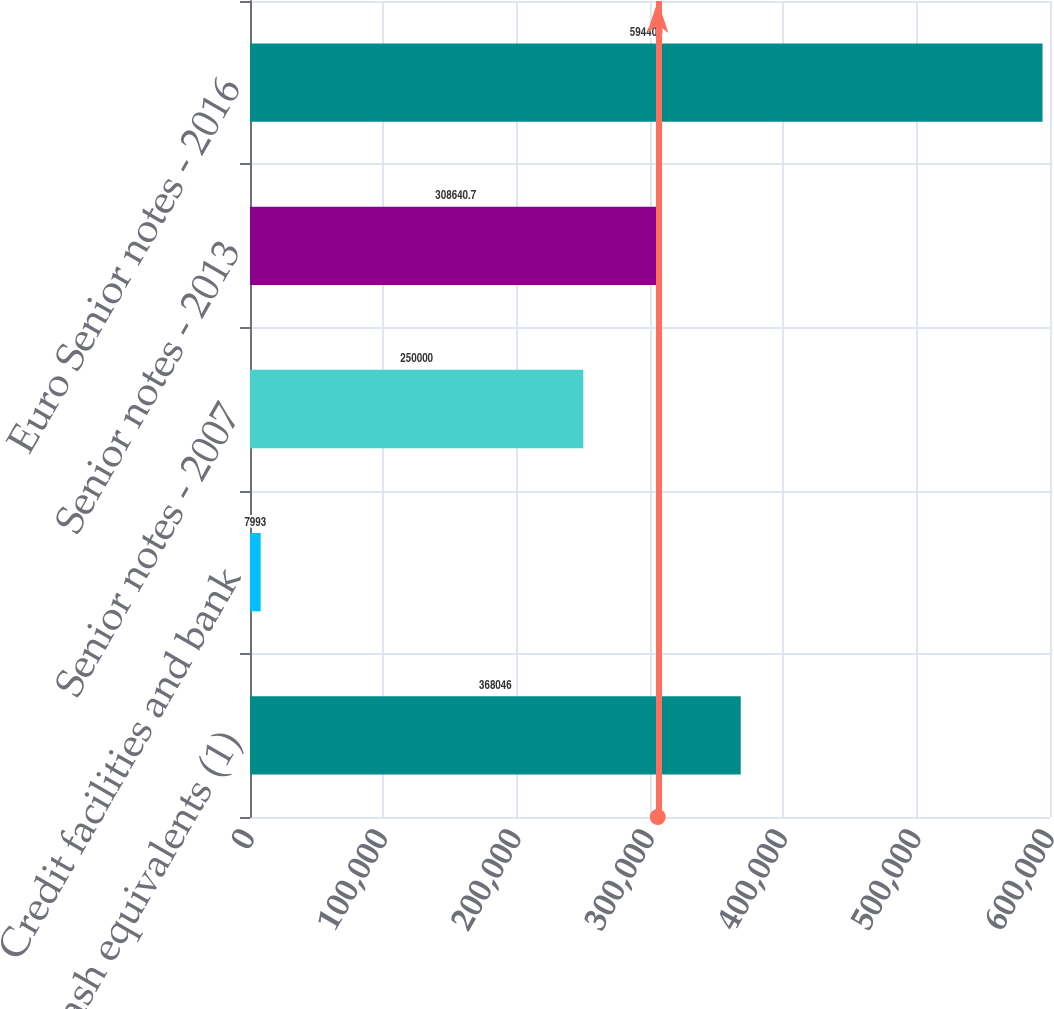<chart> <loc_0><loc_0><loc_500><loc_500><bar_chart><fcel>Cash and cash equivalents (1)<fcel>Credit facilities and bank<fcel>Senior notes - 2007<fcel>Senior notes - 2013<fcel>Euro Senior notes - 2016<nl><fcel>368046<fcel>7993<fcel>250000<fcel>308641<fcel>594400<nl></chart> 